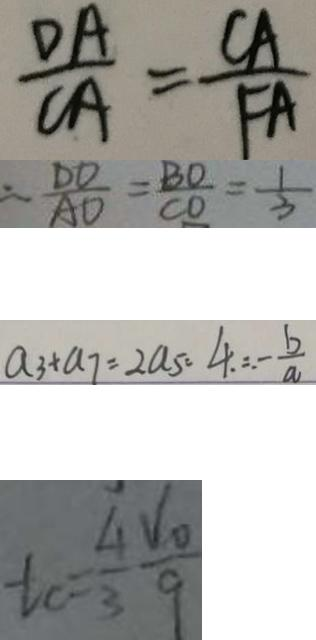Convert formula to latex. <formula><loc_0><loc_0><loc_500><loc_500>\frac { D A } { C A } = \frac { C A } { F A } 
 = \frac { D D } { A D } = \frac { B O } { C O } = \frac { 1 } { 3 } 
 a _ { 3 } + a _ { 7 } = 2 a _ { 5 } = 4 . = . - \frac { b } { a } 
 t c = \frac { 4 } { 3 } \frac { v _ { 0 } } { 9 }</formula> 